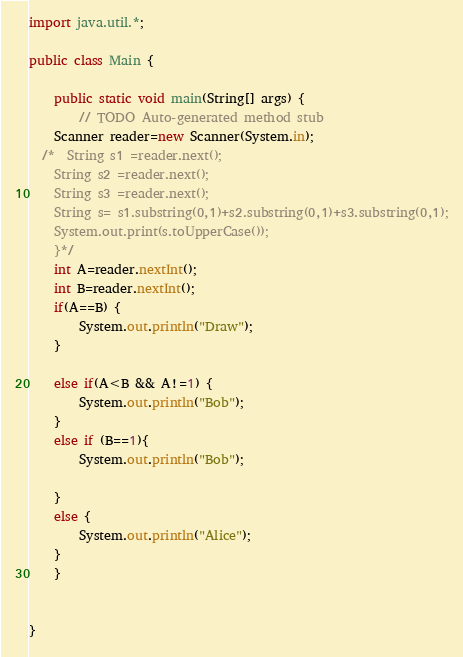<code> <loc_0><loc_0><loc_500><loc_500><_Java_>import java.util.*;

public class Main {

	public static void main(String[] args) {
		// TODO Auto-generated method stub
    Scanner reader=new Scanner(System.in);
  /*  String s1 =reader.next();
    String s2 =reader.next();
    String s3 =reader.next();
    String s= s1.substring(0,1)+s2.substring(0,1)+s3.substring(0,1);
    System.out.print(s.toUpperCase());
	}*/
	int A=reader.nextInt();
	int B=reader.nextInt();
	if(A==B) {
		System.out.println("Draw");
	}
	
	else if(A<B && A!=1) {
		System.out.println("Bob");
	}
	else if (B==1){
		System.out.println("Bob");
		
	}
	else {
		System.out.println("Alice");
	}
	}									
	

}
</code> 